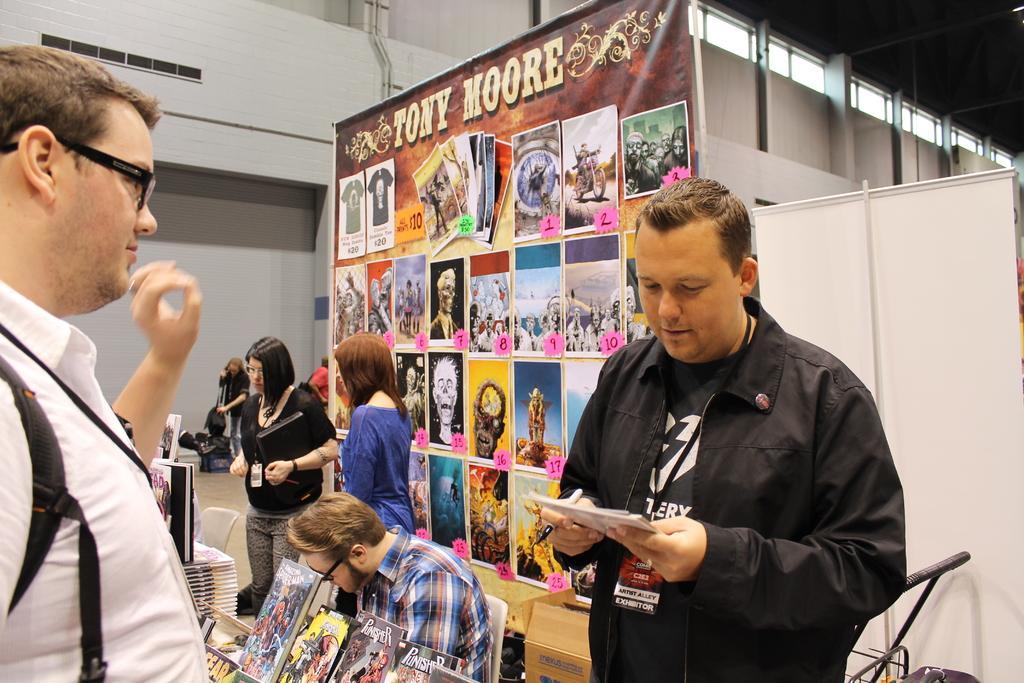How would you summarize this image in a sentence or two? In this image there is a person standing and holding a book and a pen, another person standing beside him, and at the background there are books and a name board on the table , two persons sitting on the chairs, banners attached to the poles, trolley, bags, group of people standing, air conditioner. 